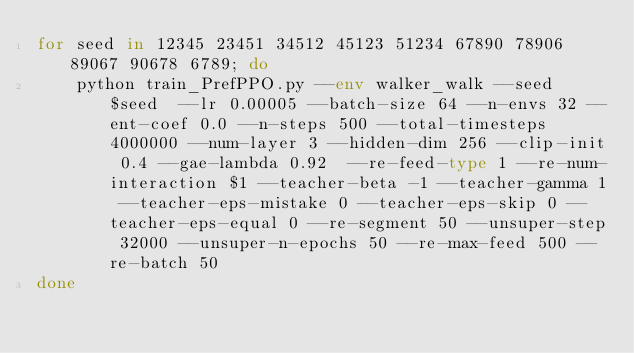<code> <loc_0><loc_0><loc_500><loc_500><_Bash_>for seed in 12345 23451 34512 45123 51234 67890 78906 89067 90678 6789; do
    python train_PrefPPO.py --env walker_walk --seed $seed  --lr 0.00005 --batch-size 64 --n-envs 32 --ent-coef 0.0 --n-steps 500 --total-timesteps 4000000 --num-layer 3 --hidden-dim 256 --clip-init 0.4 --gae-lambda 0.92  --re-feed-type 1 --re-num-interaction $1 --teacher-beta -1 --teacher-gamma 1 --teacher-eps-mistake 0 --teacher-eps-skip 0 --teacher-eps-equal 0 --re-segment 50 --unsuper-step 32000 --unsuper-n-epochs 50 --re-max-feed 500 --re-batch 50
done</code> 